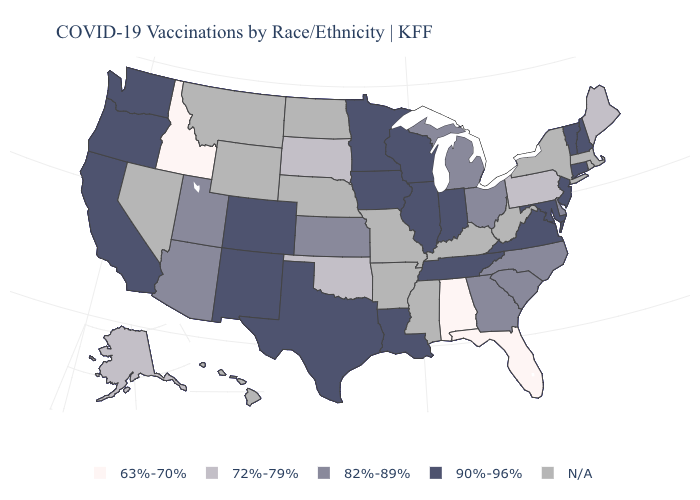Is the legend a continuous bar?
Keep it brief. No. What is the highest value in the Northeast ?
Answer briefly. 90%-96%. Name the states that have a value in the range 63%-70%?
Quick response, please. Alabama, Florida, Idaho. Which states have the highest value in the USA?
Quick response, please. California, Colorado, Connecticut, Illinois, Indiana, Iowa, Louisiana, Maryland, Minnesota, New Hampshire, New Jersey, New Mexico, Oregon, Tennessee, Texas, Vermont, Virginia, Washington, Wisconsin. What is the value of Florida?
Answer briefly. 63%-70%. Which states have the highest value in the USA?
Give a very brief answer. California, Colorado, Connecticut, Illinois, Indiana, Iowa, Louisiana, Maryland, Minnesota, New Hampshire, New Jersey, New Mexico, Oregon, Tennessee, Texas, Vermont, Virginia, Washington, Wisconsin. What is the value of South Carolina?
Quick response, please. 82%-89%. Which states have the lowest value in the USA?
Concise answer only. Alabama, Florida, Idaho. Name the states that have a value in the range 82%-89%?
Write a very short answer. Arizona, Delaware, Georgia, Kansas, Michigan, North Carolina, Ohio, South Carolina, Utah. Name the states that have a value in the range 82%-89%?
Write a very short answer. Arizona, Delaware, Georgia, Kansas, Michigan, North Carolina, Ohio, South Carolina, Utah. Does the first symbol in the legend represent the smallest category?
Keep it brief. Yes. Does the first symbol in the legend represent the smallest category?
Give a very brief answer. Yes. 